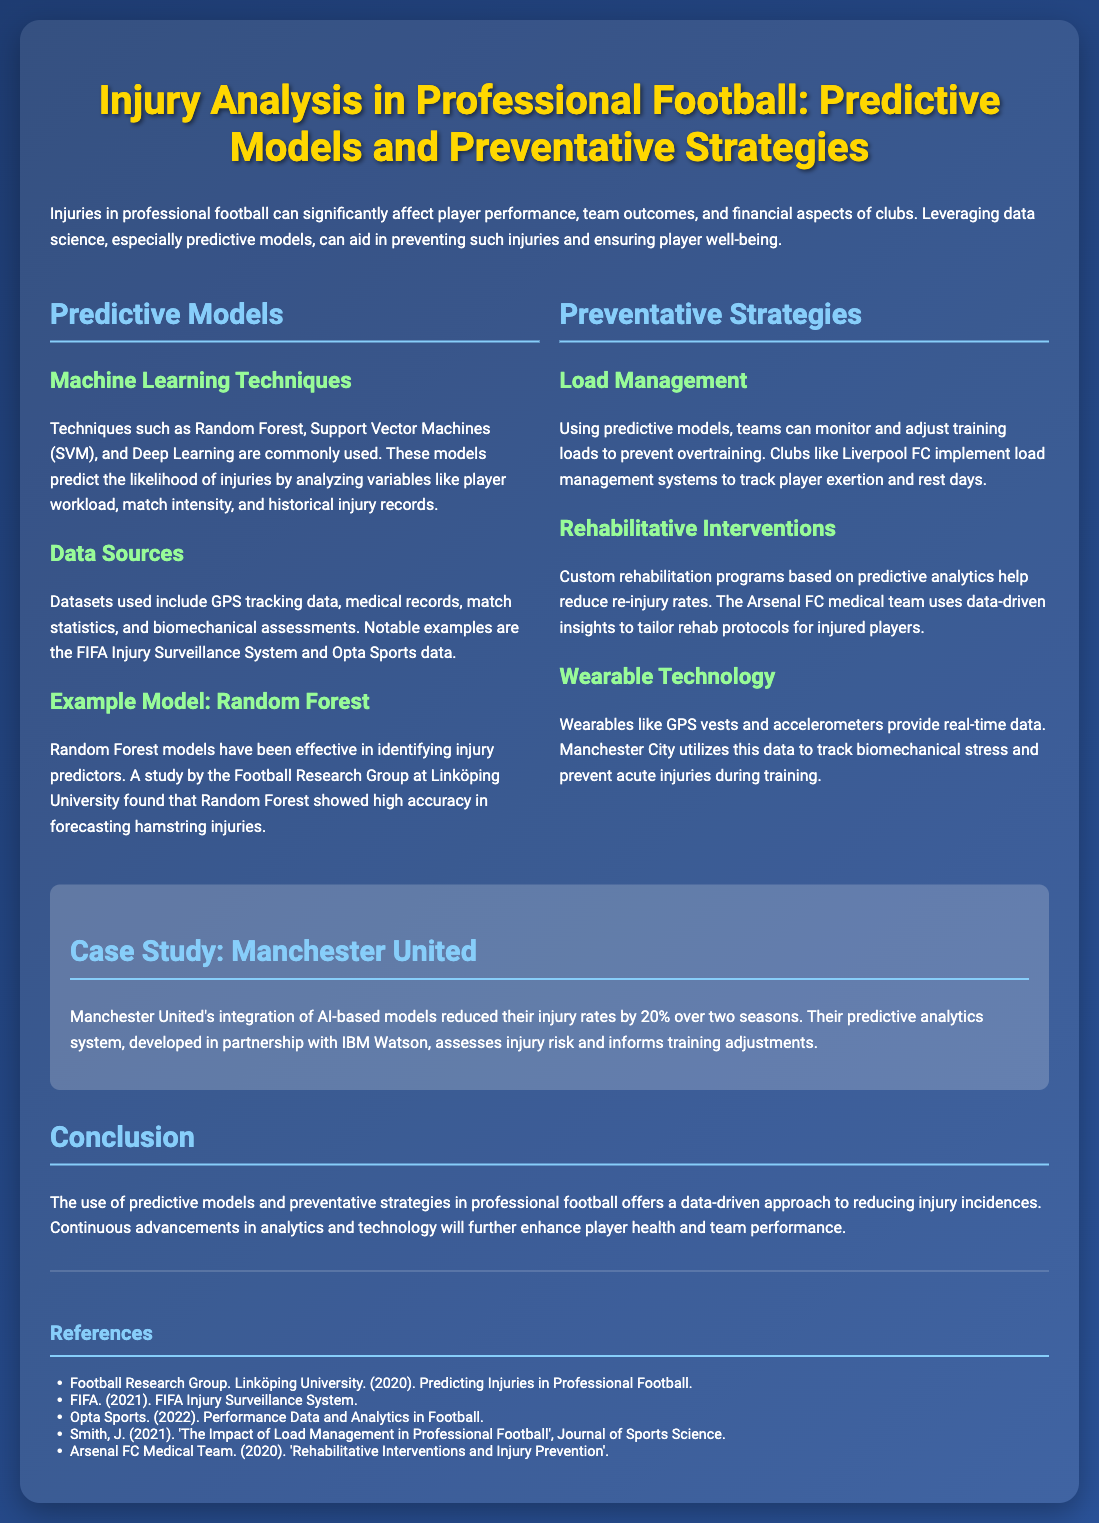what is the title of the poster? The title of the poster is prominently displayed at the top, summing up the main focus of the document.
Answer: Injury Analysis in Professional Football: Predictive Models and Preventative Strategies which machine learning technique is mentioned for injury prediction? The document lists various machine learning techniques used for injury prediction, one of which is highlighted.
Answer: Random Forest what has Manchester United achieved through AI-based models? The poster mentions a specific outcome from Manchester United's use of predictive analytics over two seasons.
Answer: reduced their injury rates by 20% which club is known for implementing load management systems? The document provides an example of a club that uses load management to adjust player training loads.
Answer: Liverpool FC what type of data sources are utilized in predictive models? The document discusses various types of data sources, one of which is particularly known for being influential in injury prediction.
Answer: GPS tracking data what is the main focus of the case study presented? The case study specifically highlights Manchester United's achievements in injury reduction through a partnership.
Answer: integration of AI-based models what technique does Manchester City use to prevent acute injuries? The document specifies a type of technology used by Manchester City to track player health.
Answer: wearable technology 